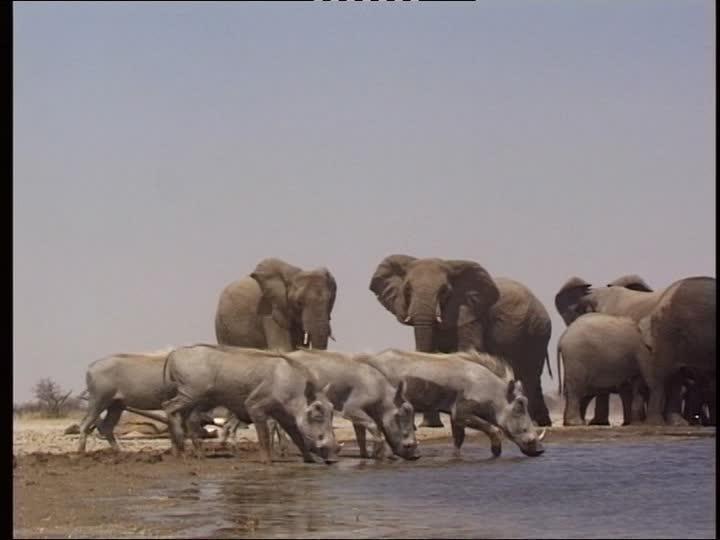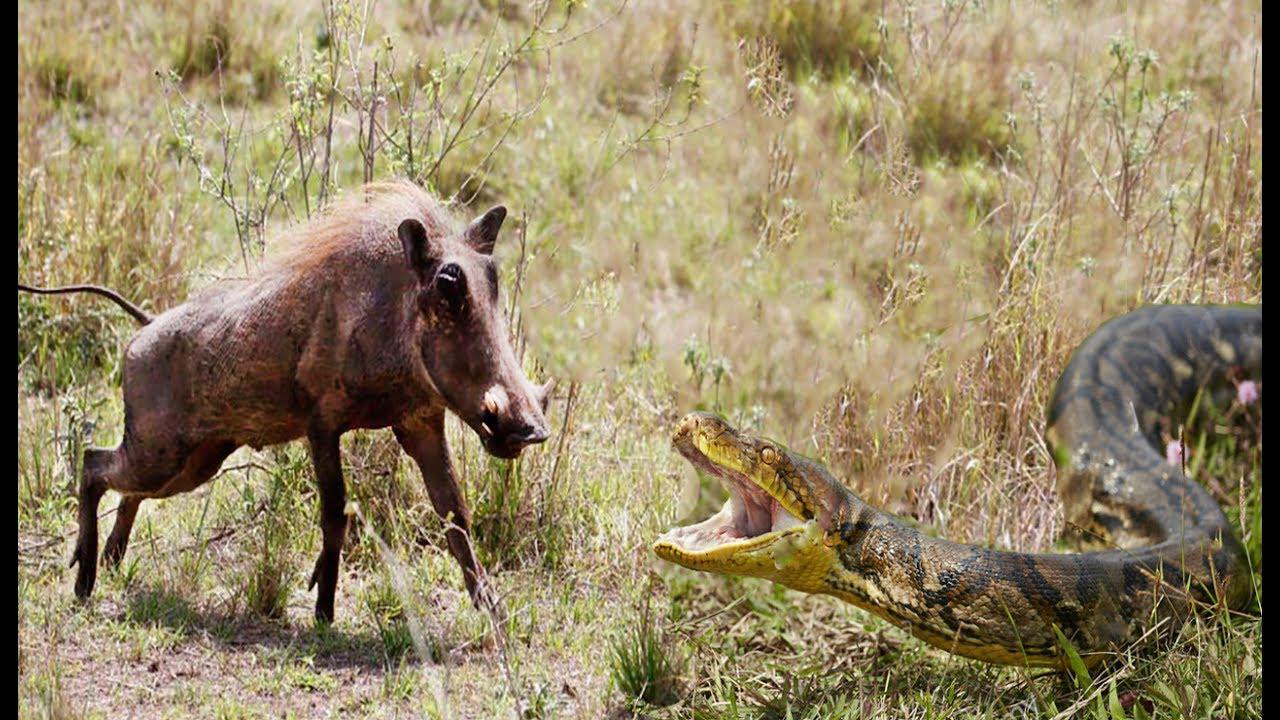The first image is the image on the left, the second image is the image on the right. Examine the images to the left and right. Is the description "There is a group of warthogs by the water." accurate? Answer yes or no. Yes. The first image is the image on the left, the second image is the image on the right. Evaluate the accuracy of this statement regarding the images: "An image shows a water source for warthogs.". Is it true? Answer yes or no. Yes. 